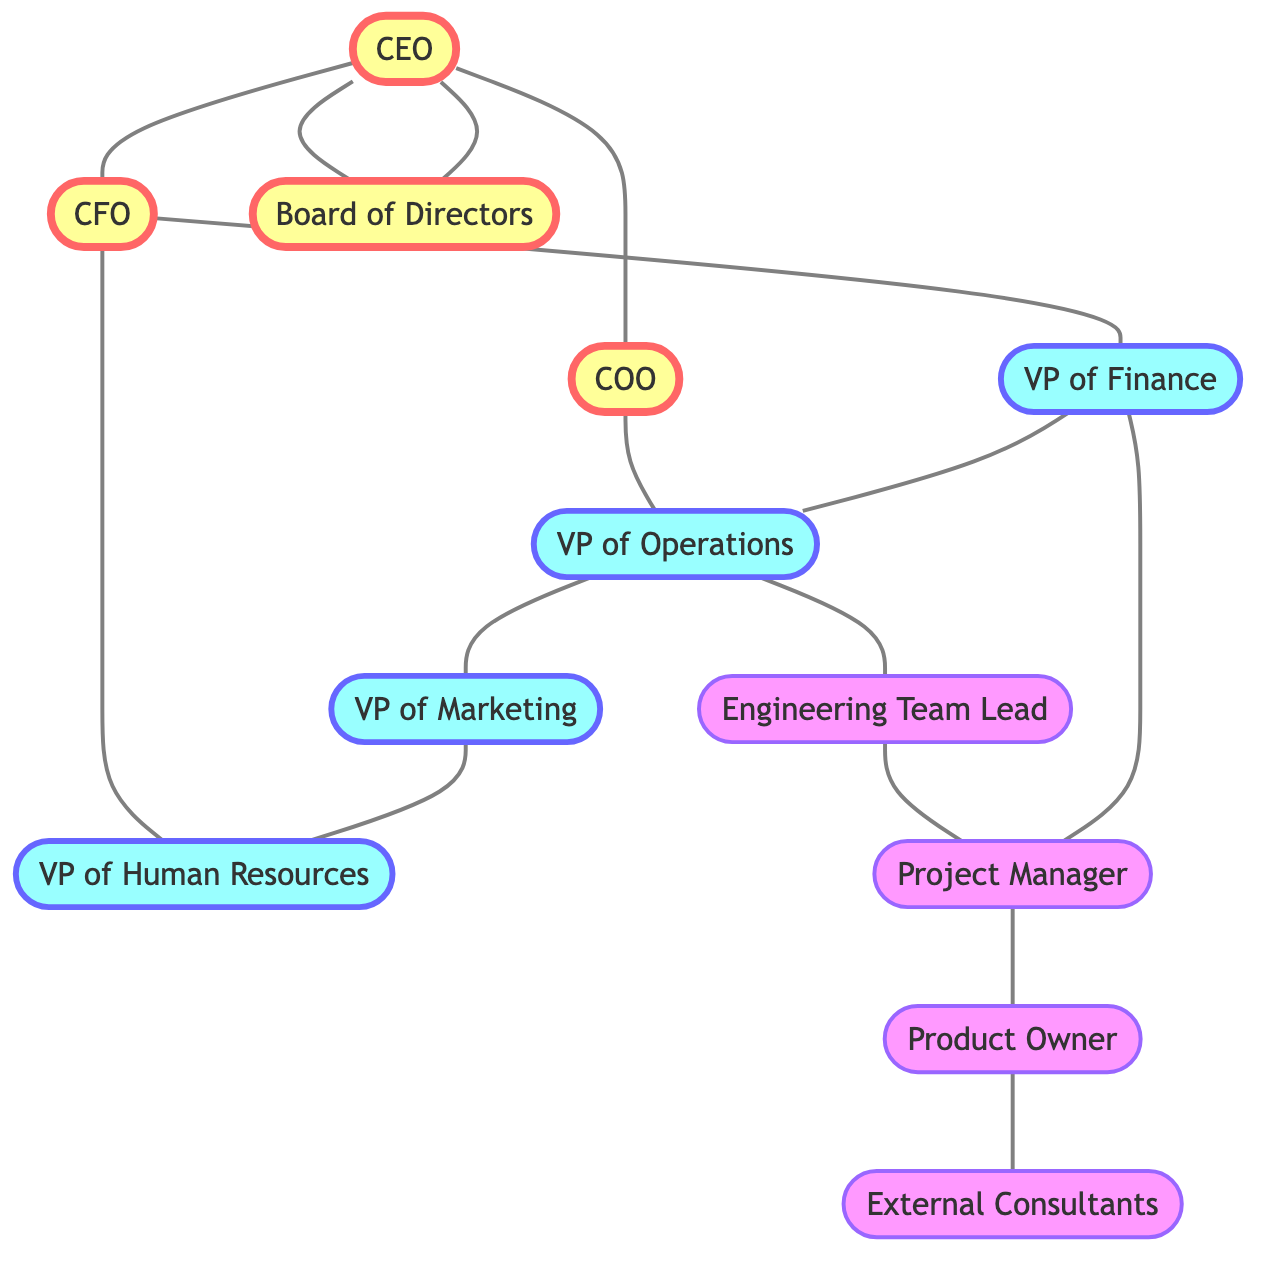What is the total number of nodes in the diagram? The diagram contains nodes for CEO, CFO, COO, Board of Directors, VP of Finance, VP of Operations, VP of Marketing, VP of Human Resources, Engineering Team Lead, Project Manager, Product Owner, and External Consultants. Counting all these nodes gives a total of 12.
Answer: 12 Which node is directly connected to the COO? The COO is directly connected to the VP of Operations. In the edge list, there is an entry where the COO connects to the VP of Operations, indicating a direct relationship between these two nodes.
Answer: VP of Operations How many edges are connected to the CFO? The CFO has 3 edges connected to it, as seen in the edge list: CFO to VP of Finance, CFO to VP of Human Resources, and CEO to CFO, totaling 3 connections.
Answer: 3 Who are the external consultants connected to? The External Consultants are directly connected to the Product Owner, according to the edge list, which specifies this relationship.
Answer: Product Owner What is the relationship between the CEO and the Board of Directors? The CEO is connected to the Board of Directors through an edge that indicates a relationship. This means the CEO reports to or interacts with the Board of Directors directly.
Answer: Connected Which role has a direct link with both the VP of Finance and the Project Manager? The Project Manager is connected to both the VP of Finance and the Product Owner. To identify this, we look at the edges related to Project Manager, which indicates its links to these two roles.
Answer: Project Manager How many unique roles are directly connected to the VP of Operations? The VP of Operations has 3 direct connections: Engineering Team Lead, VP of Marketing, and Project Manager, based on the edge definitions. Counting these reveals there are 3 unique roles.
Answer: 3 What position reports to both the CEO and the CFO? The VP of Finance reports to the CEO and also connects to the CFO. By analyzing the edges, we can see that it is connected to both, indicating reporting lines.
Answer: VP of Finance What is the nature of the connections in this graph? The connections in this graph are undirected, meaning that the relationships do not have a clear direction; each edge indicates a mutual connection between the connected nodes.
Answer: Undirected 